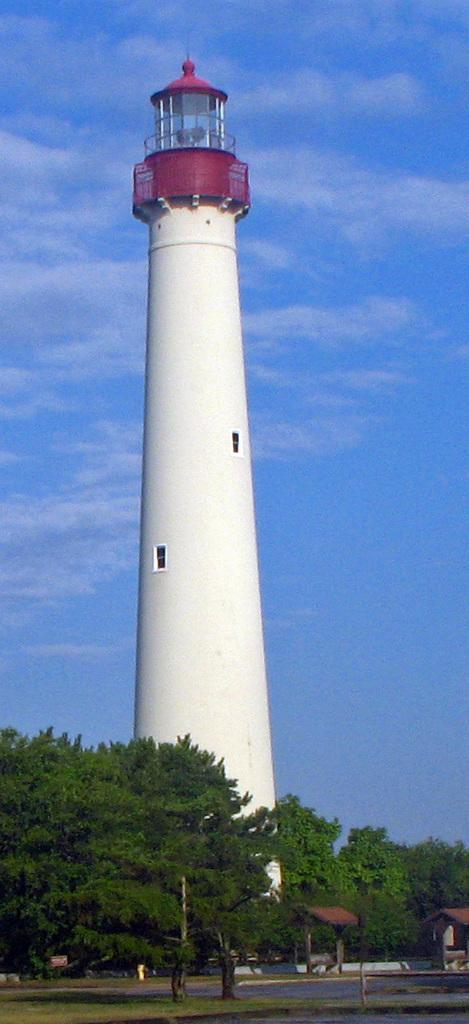What type of terrain is visible at the bottom of the image? There is grass, a road, trees, and a shed at the bottom of the image. What structure can be seen in the background of the image? There is a light tower in the background of the image. What is visible in the sky in the background of the image? The sky is visible in the background of the image. What time of day does the image appear to be taken? The image appears to be taken during the day. What type of writing can be seen on the skirt of the person in the image? There is no person or skirt present in the image. What shape is the light tower in the image? The light tower is not described in terms of its shape in the provided facts, so we cannot definitively answer this question. 